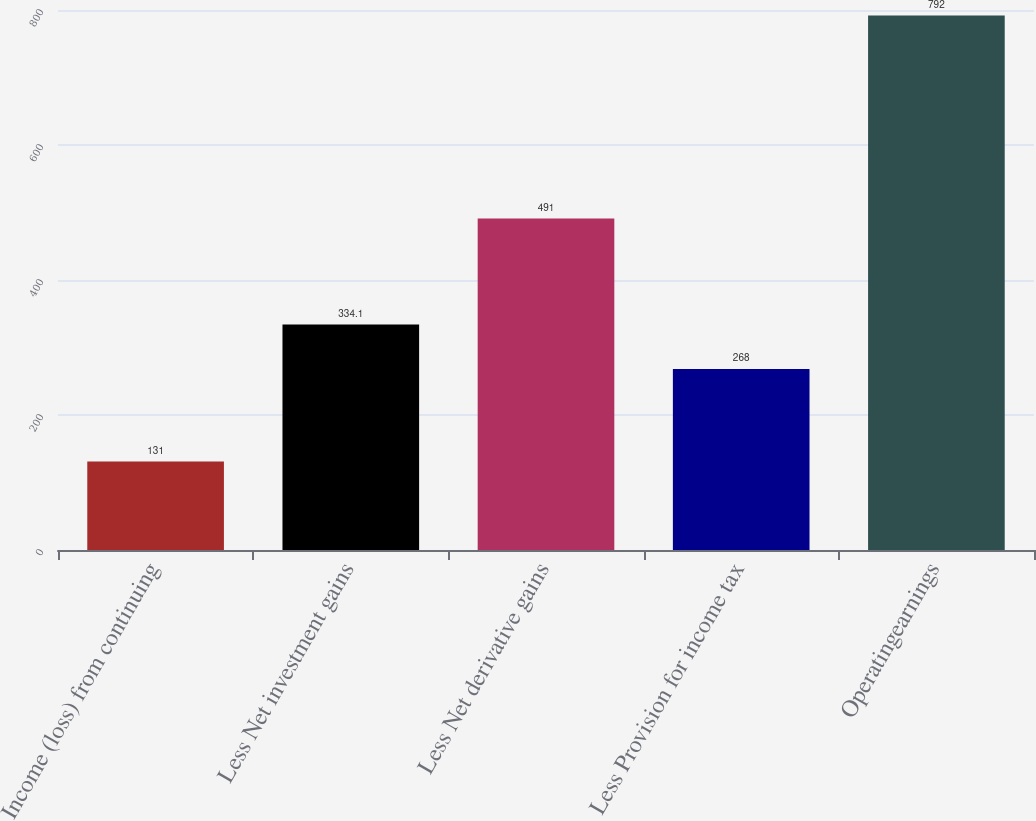<chart> <loc_0><loc_0><loc_500><loc_500><bar_chart><fcel>Income (loss) from continuing<fcel>Less Net investment gains<fcel>Less Net derivative gains<fcel>Less Provision for income tax<fcel>Operatingearnings<nl><fcel>131<fcel>334.1<fcel>491<fcel>268<fcel>792<nl></chart> 